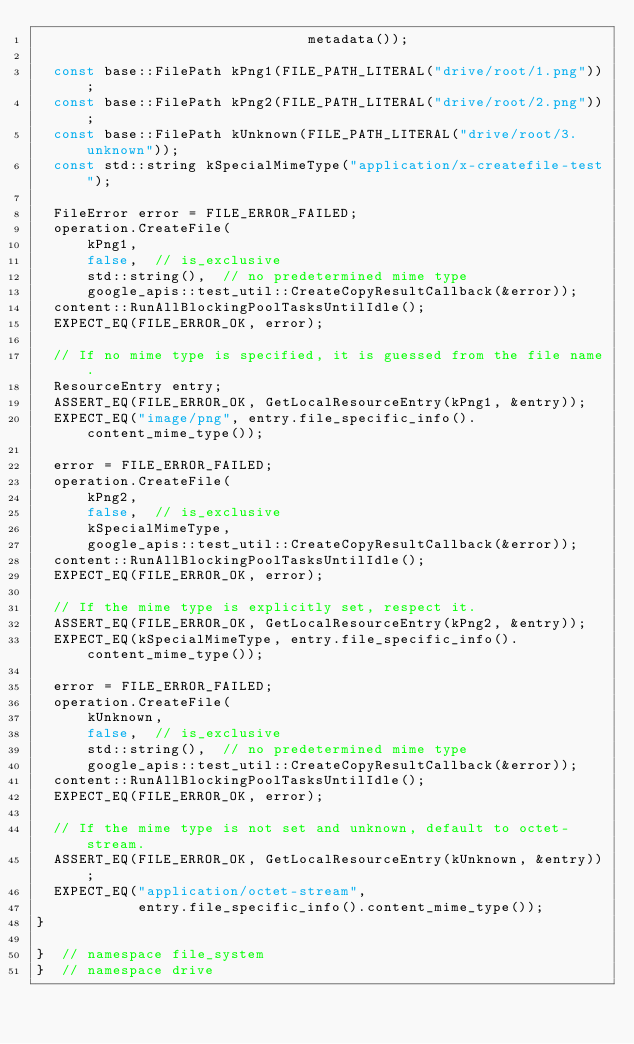Convert code to text. <code><loc_0><loc_0><loc_500><loc_500><_C++_>                                metadata());

  const base::FilePath kPng1(FILE_PATH_LITERAL("drive/root/1.png"));
  const base::FilePath kPng2(FILE_PATH_LITERAL("drive/root/2.png"));
  const base::FilePath kUnknown(FILE_PATH_LITERAL("drive/root/3.unknown"));
  const std::string kSpecialMimeType("application/x-createfile-test");

  FileError error = FILE_ERROR_FAILED;
  operation.CreateFile(
      kPng1,
      false,  // is_exclusive
      std::string(),  // no predetermined mime type
      google_apis::test_util::CreateCopyResultCallback(&error));
  content::RunAllBlockingPoolTasksUntilIdle();
  EXPECT_EQ(FILE_ERROR_OK, error);

  // If no mime type is specified, it is guessed from the file name.
  ResourceEntry entry;
  ASSERT_EQ(FILE_ERROR_OK, GetLocalResourceEntry(kPng1, &entry));
  EXPECT_EQ("image/png", entry.file_specific_info().content_mime_type());

  error = FILE_ERROR_FAILED;
  operation.CreateFile(
      kPng2,
      false,  // is_exclusive
      kSpecialMimeType,
      google_apis::test_util::CreateCopyResultCallback(&error));
  content::RunAllBlockingPoolTasksUntilIdle();
  EXPECT_EQ(FILE_ERROR_OK, error);

  // If the mime type is explicitly set, respect it.
  ASSERT_EQ(FILE_ERROR_OK, GetLocalResourceEntry(kPng2, &entry));
  EXPECT_EQ(kSpecialMimeType, entry.file_specific_info().content_mime_type());

  error = FILE_ERROR_FAILED;
  operation.CreateFile(
      kUnknown,
      false,  // is_exclusive
      std::string(),  // no predetermined mime type
      google_apis::test_util::CreateCopyResultCallback(&error));
  content::RunAllBlockingPoolTasksUntilIdle();
  EXPECT_EQ(FILE_ERROR_OK, error);

  // If the mime type is not set and unknown, default to octet-stream.
  ASSERT_EQ(FILE_ERROR_OK, GetLocalResourceEntry(kUnknown, &entry));
  EXPECT_EQ("application/octet-stream",
            entry.file_specific_info().content_mime_type());
}

}  // namespace file_system
}  // namespace drive
</code> 